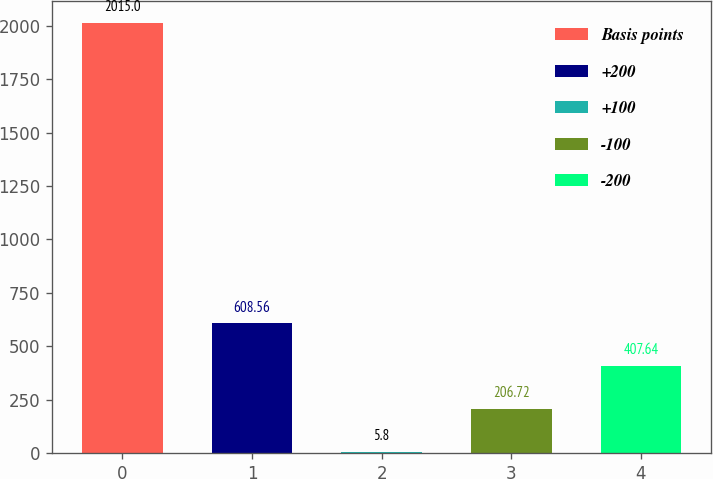Convert chart. <chart><loc_0><loc_0><loc_500><loc_500><bar_chart><fcel>Basis points<fcel>+200<fcel>+100<fcel>-100<fcel>-200<nl><fcel>2015<fcel>608.56<fcel>5.8<fcel>206.72<fcel>407.64<nl></chart> 